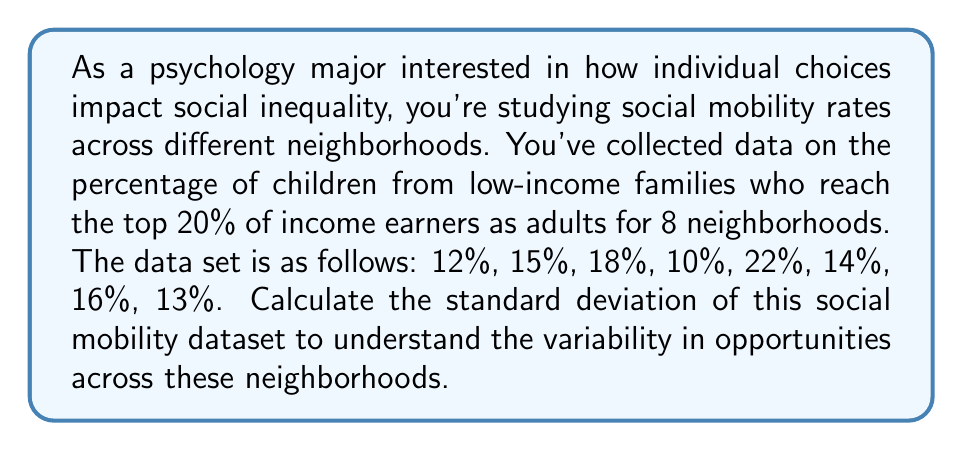Provide a solution to this math problem. To calculate the standard deviation, we'll follow these steps:

1. Calculate the mean ($\mu$) of the dataset:
   $$\mu = \frac{12 + 15 + 18 + 10 + 22 + 14 + 16 + 13}{8} = 15$$

2. Calculate the squared differences from the mean:
   $$(12 - 15)^2 = 9$$
   $$(15 - 15)^2 = 0$$
   $$(18 - 15)^2 = 9$$
   $$(10 - 15)^2 = 25$$
   $$(22 - 15)^2 = 49$$
   $$(14 - 15)^2 = 1$$
   $$(16 - 15)^2 = 1$$
   $$(13 - 15)^2 = 4$$

3. Sum the squared differences:
   $$9 + 0 + 9 + 25 + 49 + 1 + 1 + 4 = 98$$

4. Divide by (n-1), where n is the number of data points:
   $$\frac{98}{8-1} = \frac{98}{7} = 14$$

5. Take the square root to get the standard deviation:
   $$s = \sqrt{14} = 3.74$$

The standard deviation formula used is:
$$s = \sqrt{\frac{\sum_{i=1}^{n} (x_i - \mu)^2}{n - 1}}$$

where $s$ is the standard deviation, $x_i$ are the individual values, $\mu$ is the mean, and $n$ is the number of data points.
Answer: $3.74$ 